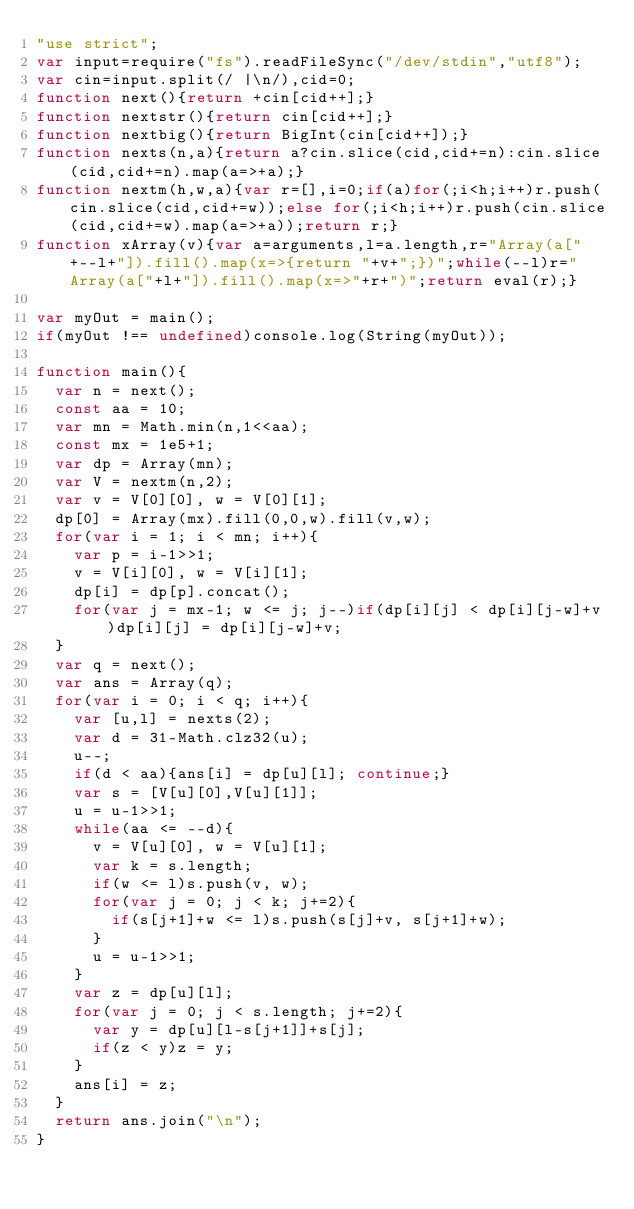<code> <loc_0><loc_0><loc_500><loc_500><_JavaScript_>"use strict";
var input=require("fs").readFileSync("/dev/stdin","utf8");
var cin=input.split(/ |\n/),cid=0;
function next(){return +cin[cid++];}
function nextstr(){return cin[cid++];}
function nextbig(){return BigInt(cin[cid++]);}
function nexts(n,a){return a?cin.slice(cid,cid+=n):cin.slice(cid,cid+=n).map(a=>+a);}
function nextm(h,w,a){var r=[],i=0;if(a)for(;i<h;i++)r.push(cin.slice(cid,cid+=w));else for(;i<h;i++)r.push(cin.slice(cid,cid+=w).map(a=>+a));return r;}
function xArray(v){var a=arguments,l=a.length,r="Array(a["+--l+"]).fill().map(x=>{return "+v+";})";while(--l)r="Array(a["+l+"]).fill().map(x=>"+r+")";return eval(r);}

var myOut = main();
if(myOut !== undefined)console.log(String(myOut));

function main(){
  var n = next();
  const aa = 10;
  var mn = Math.min(n,1<<aa);
  const mx = 1e5+1;
  var dp = Array(mn);
  var V = nextm(n,2);
  var v = V[0][0], w = V[0][1];
  dp[0] = Array(mx).fill(0,0,w).fill(v,w);
  for(var i = 1; i < mn; i++){
    var p = i-1>>1;
    v = V[i][0], w = V[i][1];
    dp[i] = dp[p].concat();
    for(var j = mx-1; w <= j; j--)if(dp[i][j] < dp[i][j-w]+v)dp[i][j] = dp[i][j-w]+v;
  }
  var q = next();
  var ans = Array(q);
  for(var i = 0; i < q; i++){
    var [u,l] = nexts(2);
    var d = 31-Math.clz32(u);
    u--;
    if(d < aa){ans[i] = dp[u][l]; continue;}
    var s = [V[u][0],V[u][1]];
    u = u-1>>1;
    while(aa <= --d){
      v = V[u][0], w = V[u][1];
      var k = s.length;
      if(w <= l)s.push(v, w);
      for(var j = 0; j < k; j+=2){
        if(s[j+1]+w <= l)s.push(s[j]+v, s[j+1]+w);
      }
      u = u-1>>1;
    }
    var z = dp[u][l];
    for(var j = 0; j < s.length; j+=2){
      var y = dp[u][l-s[j+1]]+s[j];
      if(z < y)z = y;
    }
    ans[i] = z;
  }
  return ans.join("\n");
}</code> 